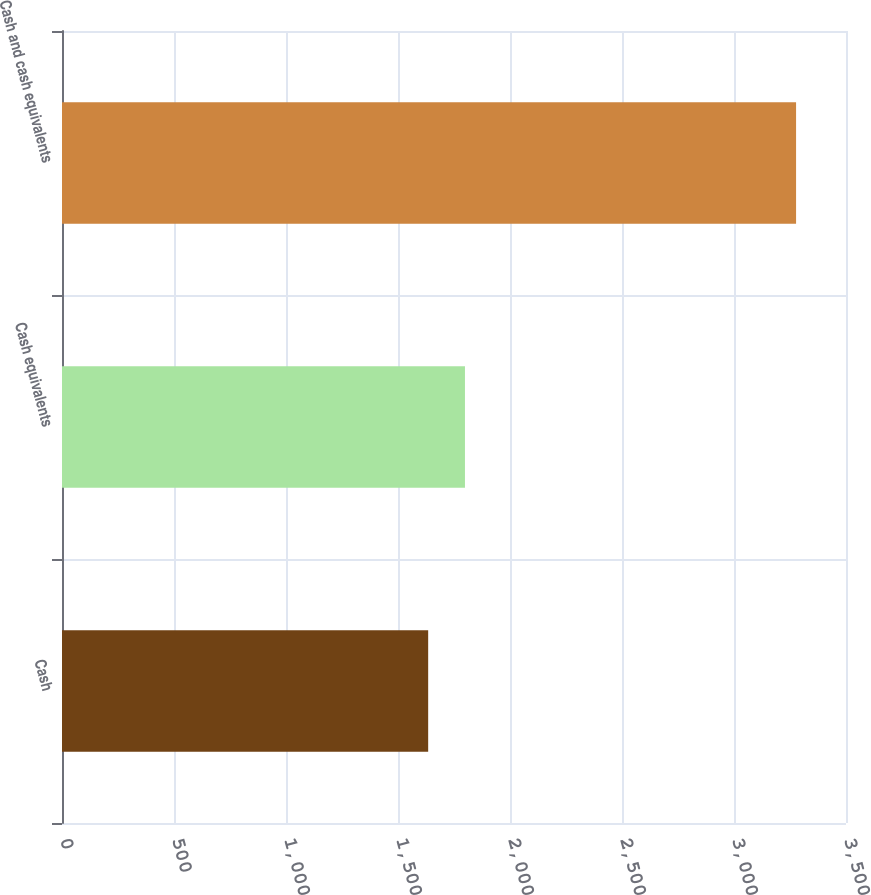Convert chart to OTSL. <chart><loc_0><loc_0><loc_500><loc_500><bar_chart><fcel>Cash<fcel>Cash equivalents<fcel>Cash and cash equivalents<nl><fcel>1634.7<fcel>1798.94<fcel>3277.1<nl></chart> 